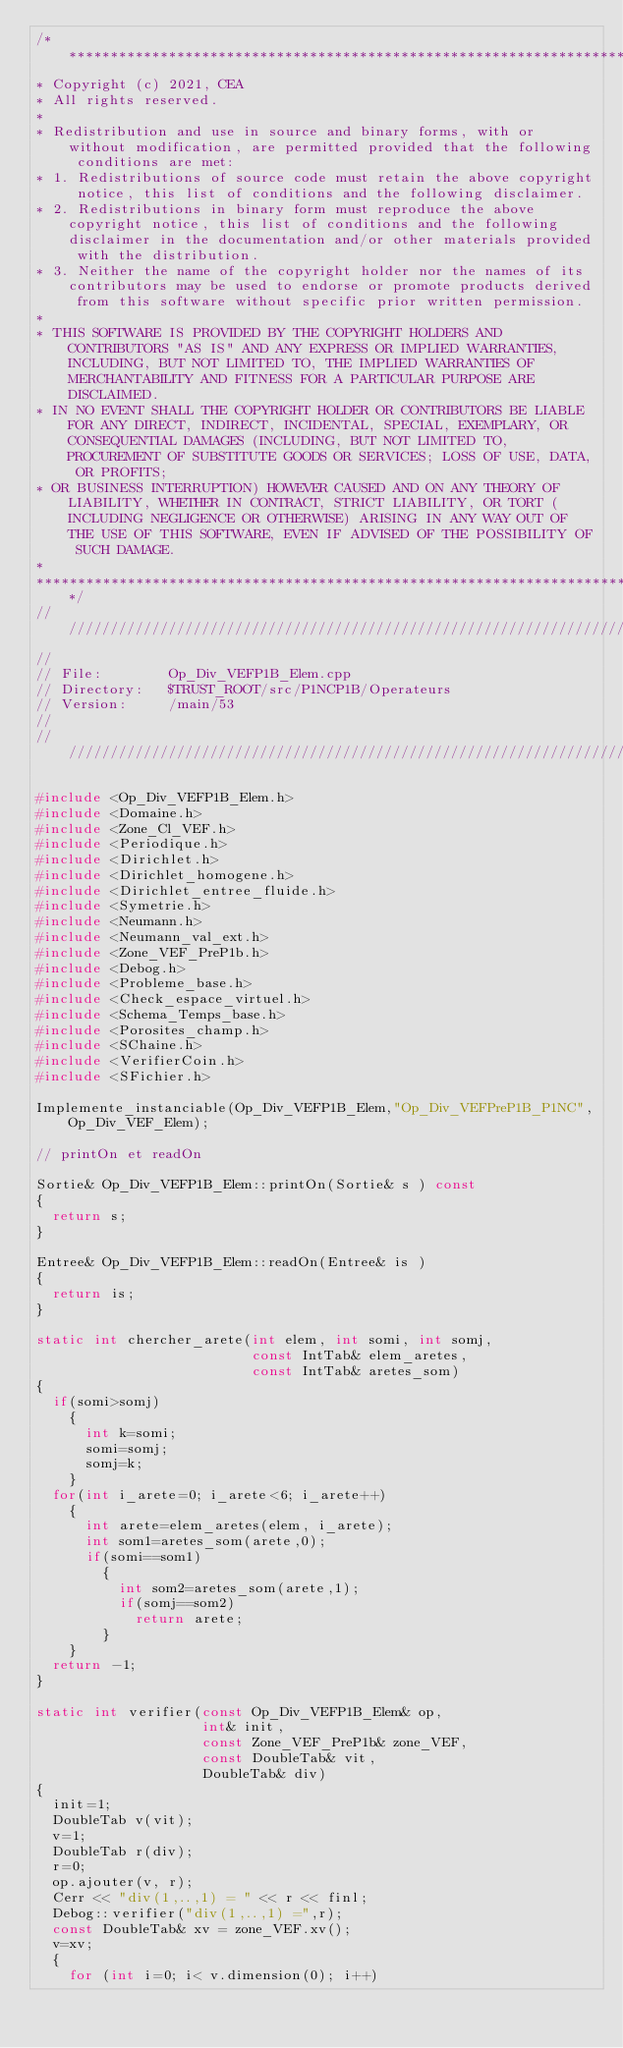Convert code to text. <code><loc_0><loc_0><loc_500><loc_500><_C++_>/****************************************************************************
* Copyright (c) 2021, CEA
* All rights reserved.
*
* Redistribution and use in source and binary forms, with or without modification, are permitted provided that the following conditions are met:
* 1. Redistributions of source code must retain the above copyright notice, this list of conditions and the following disclaimer.
* 2. Redistributions in binary form must reproduce the above copyright notice, this list of conditions and the following disclaimer in the documentation and/or other materials provided with the distribution.
* 3. Neither the name of the copyright holder nor the names of its contributors may be used to endorse or promote products derived from this software without specific prior written permission.
*
* THIS SOFTWARE IS PROVIDED BY THE COPYRIGHT HOLDERS AND CONTRIBUTORS "AS IS" AND ANY EXPRESS OR IMPLIED WARRANTIES, INCLUDING, BUT NOT LIMITED TO, THE IMPLIED WARRANTIES OF MERCHANTABILITY AND FITNESS FOR A PARTICULAR PURPOSE ARE DISCLAIMED.
* IN NO EVENT SHALL THE COPYRIGHT HOLDER OR CONTRIBUTORS BE LIABLE FOR ANY DIRECT, INDIRECT, INCIDENTAL, SPECIAL, EXEMPLARY, OR CONSEQUENTIAL DAMAGES (INCLUDING, BUT NOT LIMITED TO, PROCUREMENT OF SUBSTITUTE GOODS OR SERVICES; LOSS OF USE, DATA, OR PROFITS;
* OR BUSINESS INTERRUPTION) HOWEVER CAUSED AND ON ANY THEORY OF LIABILITY, WHETHER IN CONTRACT, STRICT LIABILITY, OR TORT (INCLUDING NEGLIGENCE OR OTHERWISE) ARISING IN ANY WAY OUT OF THE USE OF THIS SOFTWARE, EVEN IF ADVISED OF THE POSSIBILITY OF SUCH DAMAGE.
*
*****************************************************************************/
//////////////////////////////////////////////////////////////////////////////
//
// File:        Op_Div_VEFP1B_Elem.cpp
// Directory:   $TRUST_ROOT/src/P1NCP1B/Operateurs
// Version:     /main/53
//
//////////////////////////////////////////////////////////////////////////////

#include <Op_Div_VEFP1B_Elem.h>
#include <Domaine.h>
#include <Zone_Cl_VEF.h>
#include <Periodique.h>
#include <Dirichlet.h>
#include <Dirichlet_homogene.h>
#include <Dirichlet_entree_fluide.h>
#include <Symetrie.h>
#include <Neumann.h>
#include <Neumann_val_ext.h>
#include <Zone_VEF_PreP1b.h>
#include <Debog.h>
#include <Probleme_base.h>
#include <Check_espace_virtuel.h>
#include <Schema_Temps_base.h>
#include <Porosites_champ.h>
#include <SChaine.h>
#include <VerifierCoin.h>
#include <SFichier.h>

Implemente_instanciable(Op_Div_VEFP1B_Elem,"Op_Div_VEFPreP1B_P1NC",Op_Div_VEF_Elem);

// printOn et readOn

Sortie& Op_Div_VEFP1B_Elem::printOn(Sortie& s ) const
{
  return s;
}

Entree& Op_Div_VEFP1B_Elem::readOn(Entree& is )
{
  return is;
}

static int chercher_arete(int elem, int somi, int somj,
                          const IntTab& elem_aretes,
                          const IntTab& aretes_som)
{
  if(somi>somj)
    {
      int k=somi;
      somi=somj;
      somj=k;
    }
  for(int i_arete=0; i_arete<6; i_arete++)
    {
      int arete=elem_aretes(elem, i_arete);
      int som1=aretes_som(arete,0);
      if(somi==som1)
        {
          int som2=aretes_som(arete,1);
          if(somj==som2)
            return arete;
        }
    }
  return -1;
}

static int verifier(const Op_Div_VEFP1B_Elem& op,
                    int& init,
                    const Zone_VEF_PreP1b& zone_VEF,
                    const DoubleTab& vit,
                    DoubleTab& div)
{
  init=1;
  DoubleTab v(vit);
  v=1;
  DoubleTab r(div);
  r=0;
  op.ajouter(v, r);
  Cerr << "div(1,..,1) = " << r << finl;
  Debog::verifier("div(1,..,1) =",r);
  const DoubleTab& xv = zone_VEF.xv();
  v=xv;
  {
    for (int i=0; i< v.dimension(0); i++)</code> 